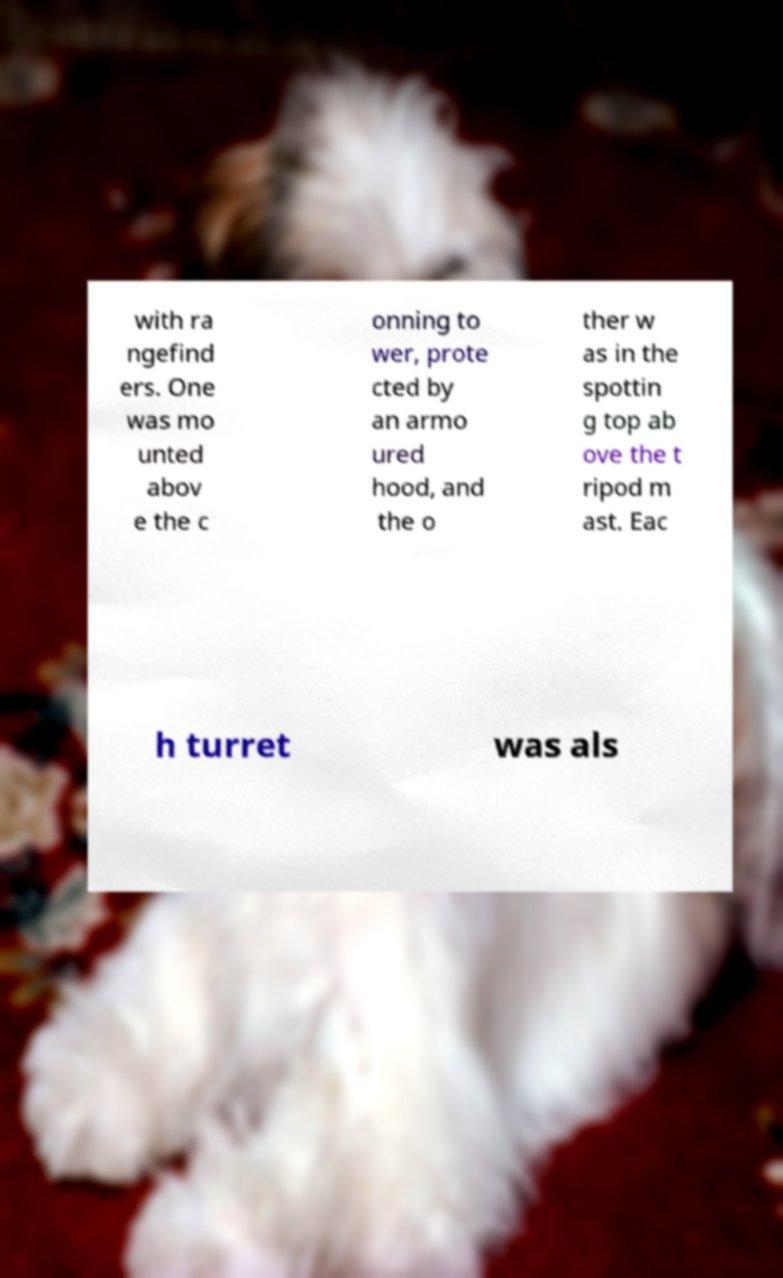Please identify and transcribe the text found in this image. with ra ngefind ers. One was mo unted abov e the c onning to wer, prote cted by an armo ured hood, and the o ther w as in the spottin g top ab ove the t ripod m ast. Eac h turret was als 